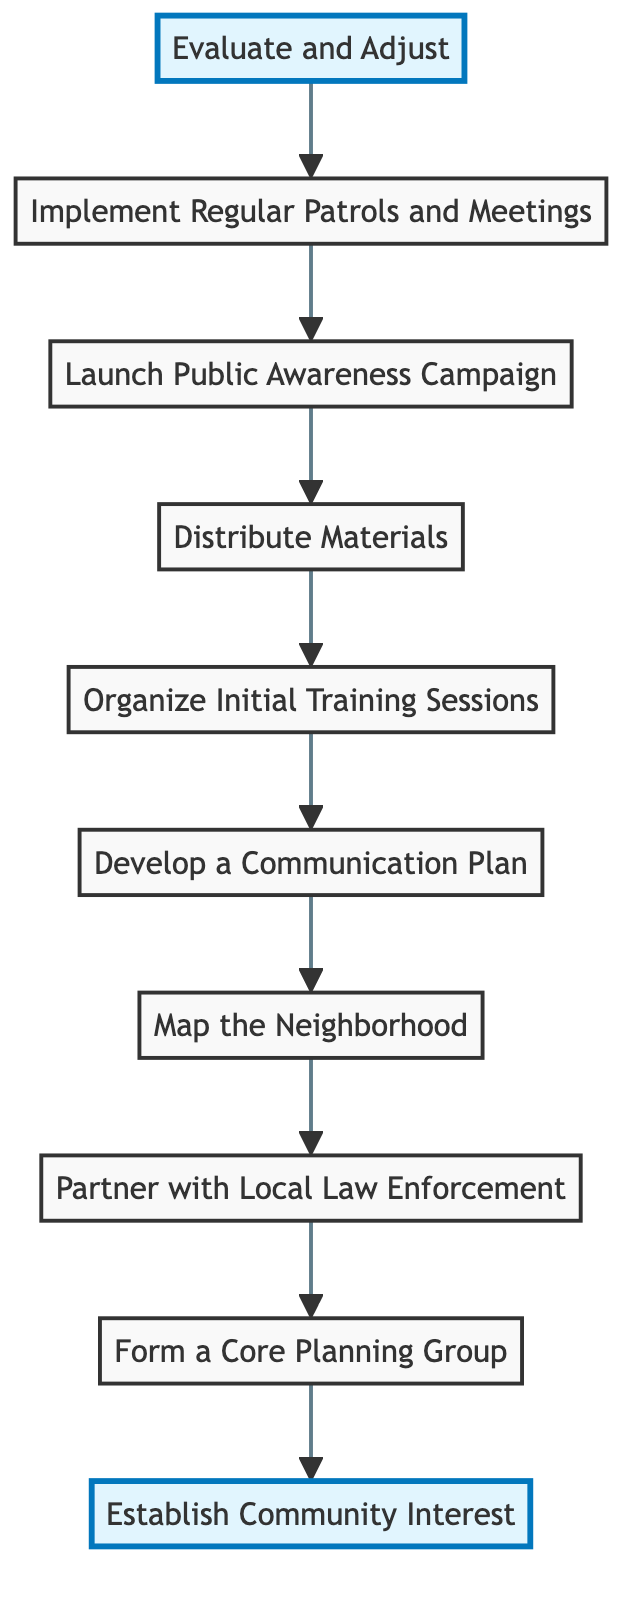What is the first step in the Neighborhood Watch Program? The flowchart indicates that the first step (bottom node) is "Establish Community Interest," which starts the implementation of the Neighborhood Watch Program.
Answer: Establish Community Interest How many steps are in the diagram? By counting each node from the bottom to the top, there are a total of ten distinct steps represented in the flowchart.
Answer: 10 What step comes immediately after "Map the Neighborhood"? In the diagram, the step that directly follows "Map the Neighborhood" is "Partner with Local Law Enforcement."
Answer: Partner with Local Law Enforcement Which step comes before "Evaluate and Adjust"? The step that occurs directly prior to "Evaluate and Adjust" is "Implement Regular Patrols and Meetings," showing the flow of the program's development.
Answer: Implement Regular Patrols and Meetings Which steps are highlighted in the flowchart? The highlighted steps indicate the start and end points of the flow: "Establish Community Interest" at the bottom and "Evaluate and Adjust" at the top represent the initiation and review stages of the program.
Answer: Establish Community Interest, Evaluate and Adjust What is the last action taken in the implementation process? The last action, as noted in the flowchart, is "Evaluate and Adjust," which indicates the program's review and improvement phase after all other steps have been completed.
Answer: Evaluate and Adjust Which step requires the involvement of local law enforcement? "Partner with Local Law Enforcement" explicitly mentions collaboration with law enforcement, making it the key step where their involvement is necessary for training and support.
Answer: Partner with Local Law Enforcement How many steps are related to communication in the program? The flowchart reflects two specific steps regarding communication: "Develop a Communication Plan" and "Distribute Materials," emphasizing the importance of communication in the Neighborhood Watch Program.
Answer: 2 Which step is placed directly above "Distribute Materials"? In the diagram's flow, "Organize Initial Training Sessions" appears directly above "Distribute Materials," showing the sequence of actions before providing materials to participants.
Answer: Organize Initial Training Sessions What is the main purpose of the "Launch Public Awareness Campaign"? The objective of "Launch Public Awareness Campaign" is to inform and engage the wider community about the Neighborhood Watch Program and encourage participation, showing an important outreach component.
Answer: Inform and engage the community 